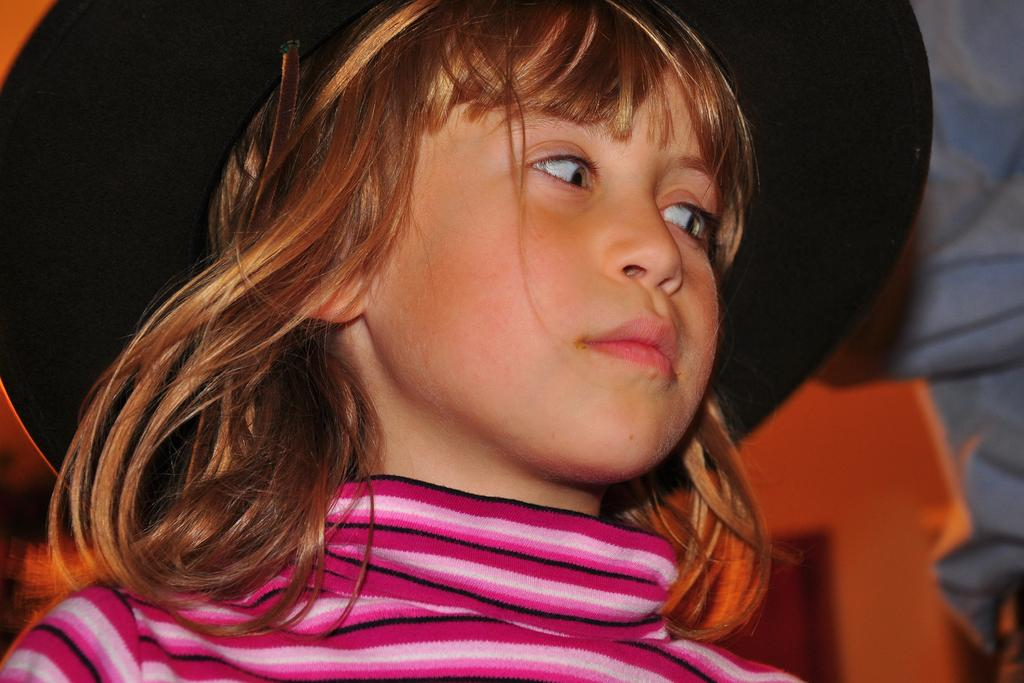What can be seen in the image? There is a person in the image. What is the person wearing? The person is wearing a pink and black t-shirt and a black hat. What direction is the person looking? The person is watching towards the right. What type of crate can be seen in the image? There is no crate present in the image. How many sticks are being used by the person in the image? There are no sticks visible in the image. 